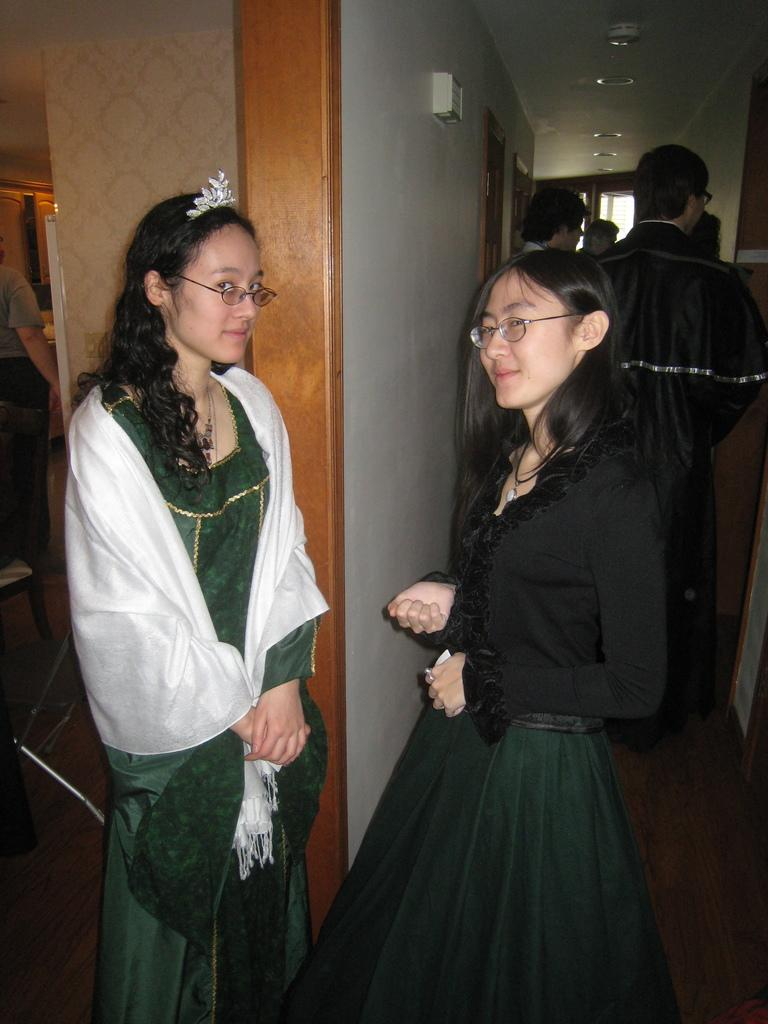How many women are in the image? There are two women in the image. What are the women doing in the image? The women are standing face to face and posing for the picture. Are there any other people visible in the image? Yes, there are other people standing behind the two women. What type of kettle is being used by the women in the image? There is no kettle present in the image; it features two women standing face to face and posing for a picture. How many planes can be seen flying in the background of the image? There are no planes visible in the image; it focuses on the two women and the people standing behind them. 